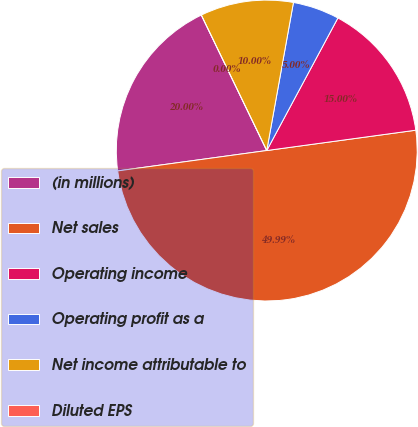Convert chart to OTSL. <chart><loc_0><loc_0><loc_500><loc_500><pie_chart><fcel>(in millions)<fcel>Net sales<fcel>Operating income<fcel>Operating profit as a<fcel>Net income attributable to<fcel>Diluted EPS<nl><fcel>20.0%<fcel>49.99%<fcel>15.0%<fcel>5.0%<fcel>10.0%<fcel>0.0%<nl></chart> 